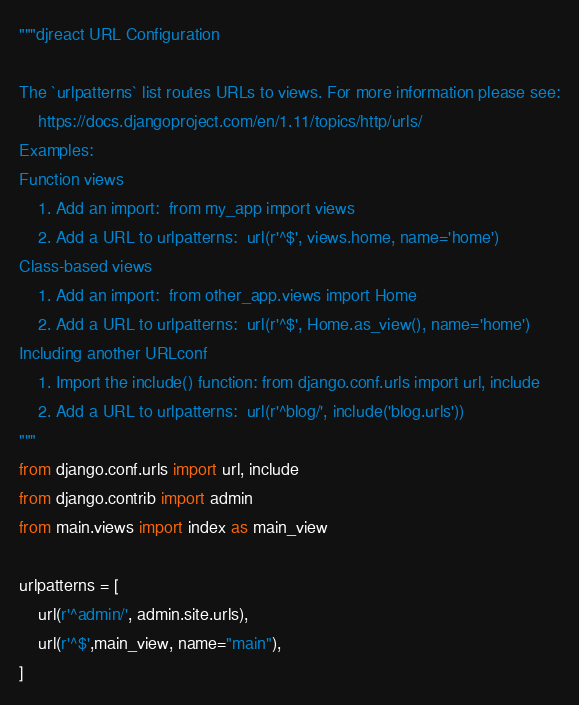Convert code to text. <code><loc_0><loc_0><loc_500><loc_500><_Python_>"""djreact URL Configuration

The `urlpatterns` list routes URLs to views. For more information please see:
    https://docs.djangoproject.com/en/1.11/topics/http/urls/
Examples:
Function views
    1. Add an import:  from my_app import views
    2. Add a URL to urlpatterns:  url(r'^$', views.home, name='home')
Class-based views
    1. Add an import:  from other_app.views import Home
    2. Add a URL to urlpatterns:  url(r'^$', Home.as_view(), name='home')
Including another URLconf
    1. Import the include() function: from django.conf.urls import url, include
    2. Add a URL to urlpatterns:  url(r'^blog/', include('blog.urls'))
"""
from django.conf.urls import url, include
from django.contrib import admin
from main.views import index as main_view

urlpatterns = [
    url(r'^admin/', admin.site.urls),
    url(r'^$',main_view, name="main"),
]
</code> 